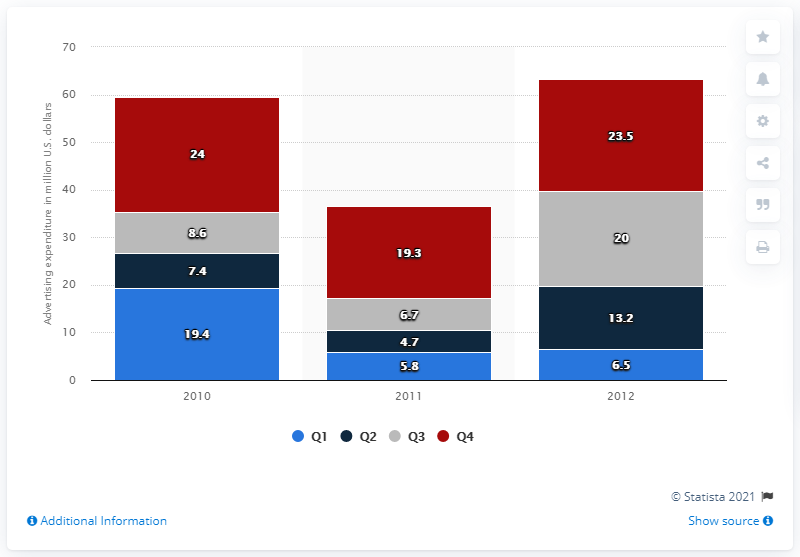Give some essential details in this illustration. Duracell spent $23.5 million on advertising in the fourth quarter of 2012. 